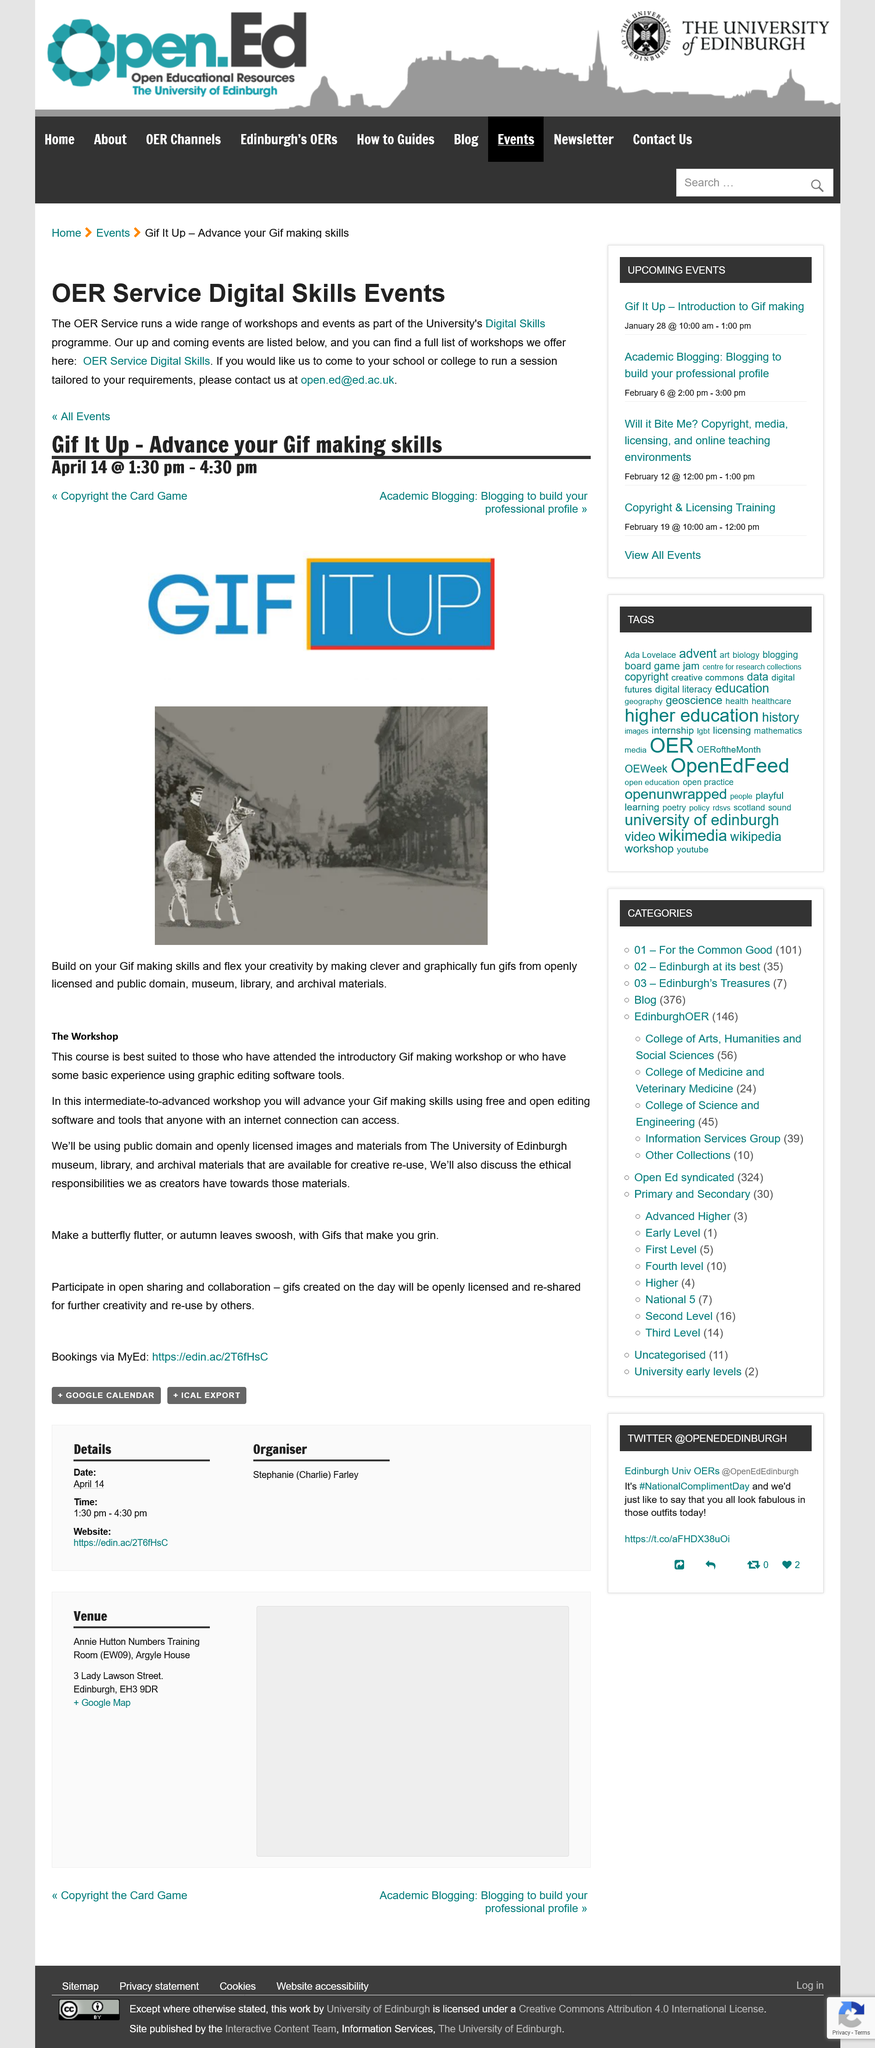Draw attention to some important aspects in this diagram. The use of open editing software is employed by this workshop. At this workshop, participants will learn the skills necessary to create GIFs, including the use of various software and techniques for creating animations. This workshop is geared towards intermediate to advanced level participants and utilizes resources from the University of Edinburgh. 